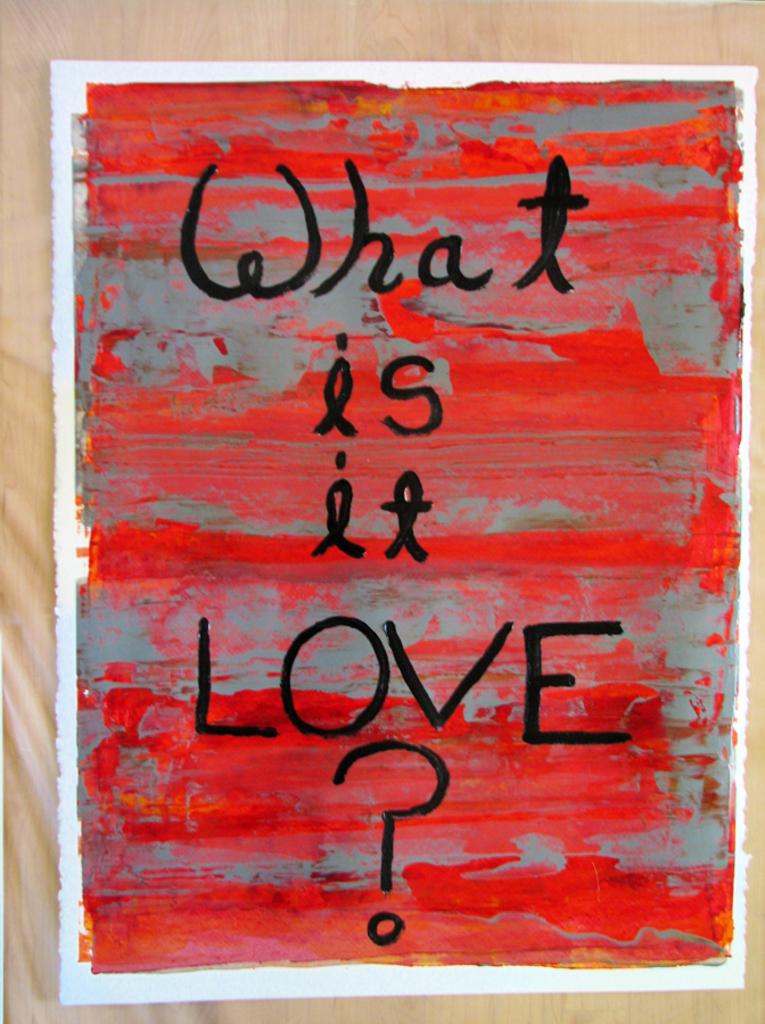What is this art piece asking?
Your answer should be very brief. What is it love?. 